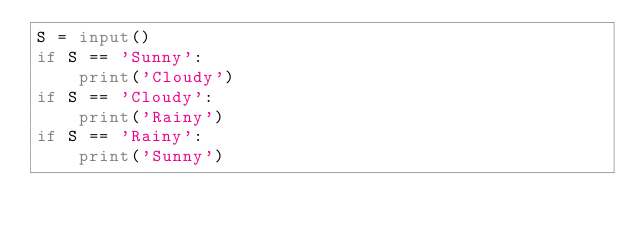Convert code to text. <code><loc_0><loc_0><loc_500><loc_500><_Python_>S = input()
if S == 'Sunny':
    print('Cloudy')
if S == 'Cloudy':
    print('Rainy')
if S == 'Rainy':
    print('Sunny')</code> 